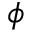Convert formula to latex. <formula><loc_0><loc_0><loc_500><loc_500>\phi</formula> 